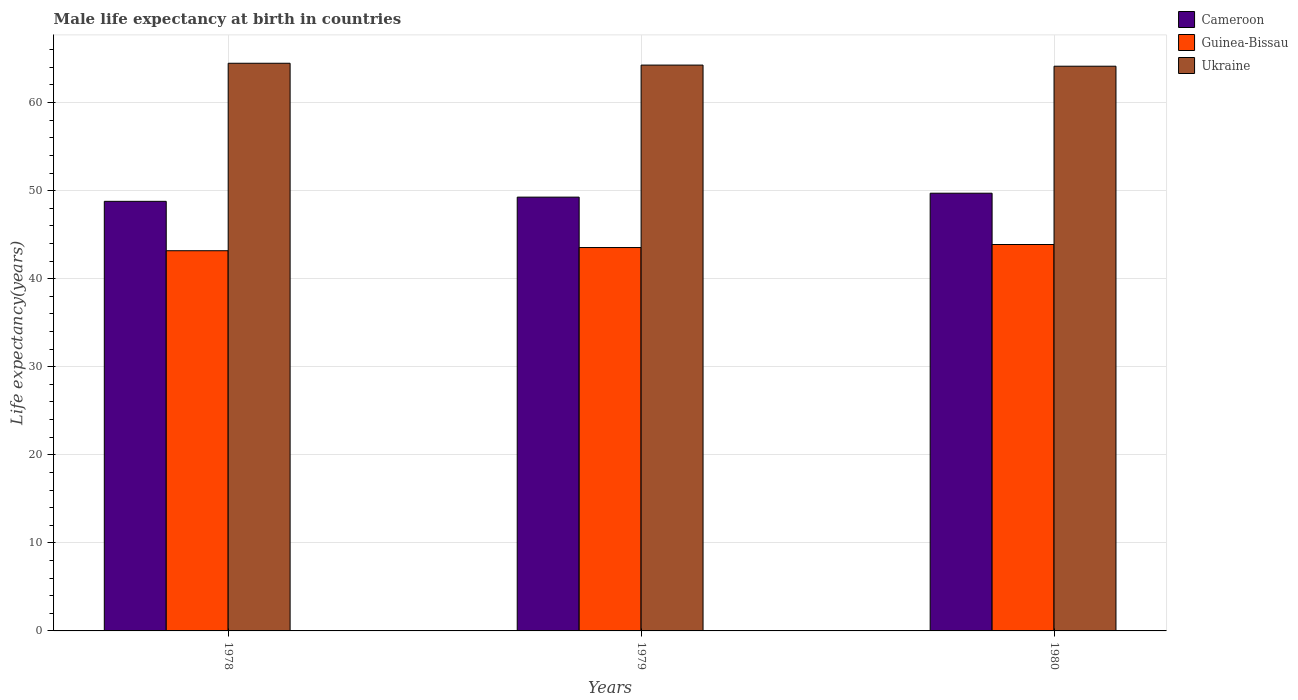How many different coloured bars are there?
Give a very brief answer. 3. Are the number of bars per tick equal to the number of legend labels?
Give a very brief answer. Yes. How many bars are there on the 3rd tick from the left?
Keep it short and to the point. 3. What is the label of the 2nd group of bars from the left?
Your answer should be very brief. 1979. What is the male life expectancy at birth in Guinea-Bissau in 1979?
Offer a very short reply. 43.54. Across all years, what is the maximum male life expectancy at birth in Cameroon?
Give a very brief answer. 49.71. Across all years, what is the minimum male life expectancy at birth in Cameroon?
Offer a very short reply. 48.79. In which year was the male life expectancy at birth in Ukraine minimum?
Your response must be concise. 1980. What is the total male life expectancy at birth in Ukraine in the graph?
Keep it short and to the point. 192.86. What is the difference between the male life expectancy at birth in Guinea-Bissau in 1978 and that in 1979?
Offer a very short reply. -0.36. What is the difference between the male life expectancy at birth in Cameroon in 1978 and the male life expectancy at birth in Guinea-Bissau in 1980?
Provide a short and direct response. 4.9. What is the average male life expectancy at birth in Ukraine per year?
Your response must be concise. 64.29. In the year 1978, what is the difference between the male life expectancy at birth in Guinea-Bissau and male life expectancy at birth in Ukraine?
Keep it short and to the point. -21.29. In how many years, is the male life expectancy at birth in Guinea-Bissau greater than 2 years?
Offer a very short reply. 3. What is the ratio of the male life expectancy at birth in Guinea-Bissau in 1978 to that in 1980?
Ensure brevity in your answer.  0.98. Is the difference between the male life expectancy at birth in Guinea-Bissau in 1978 and 1980 greater than the difference between the male life expectancy at birth in Ukraine in 1978 and 1980?
Provide a succinct answer. No. What is the difference between the highest and the second highest male life expectancy at birth in Ukraine?
Keep it short and to the point. 0.21. What is the difference between the highest and the lowest male life expectancy at birth in Guinea-Bissau?
Ensure brevity in your answer.  0.71. Is the sum of the male life expectancy at birth in Ukraine in 1978 and 1980 greater than the maximum male life expectancy at birth in Cameroon across all years?
Offer a terse response. Yes. What does the 3rd bar from the left in 1979 represents?
Keep it short and to the point. Ukraine. What does the 2nd bar from the right in 1978 represents?
Your response must be concise. Guinea-Bissau. Is it the case that in every year, the sum of the male life expectancy at birth in Guinea-Bissau and male life expectancy at birth in Cameroon is greater than the male life expectancy at birth in Ukraine?
Your answer should be compact. Yes. How many bars are there?
Provide a short and direct response. 9. Are all the bars in the graph horizontal?
Offer a very short reply. No. How many years are there in the graph?
Make the answer very short. 3. What is the difference between two consecutive major ticks on the Y-axis?
Keep it short and to the point. 10. Does the graph contain any zero values?
Provide a succinct answer. No. How are the legend labels stacked?
Your response must be concise. Vertical. What is the title of the graph?
Offer a very short reply. Male life expectancy at birth in countries. What is the label or title of the Y-axis?
Make the answer very short. Life expectancy(years). What is the Life expectancy(years) in Cameroon in 1978?
Provide a succinct answer. 48.79. What is the Life expectancy(years) of Guinea-Bissau in 1978?
Offer a terse response. 43.18. What is the Life expectancy(years) of Ukraine in 1978?
Give a very brief answer. 64.47. What is the Life expectancy(years) of Cameroon in 1979?
Give a very brief answer. 49.26. What is the Life expectancy(years) of Guinea-Bissau in 1979?
Offer a terse response. 43.54. What is the Life expectancy(years) of Ukraine in 1979?
Give a very brief answer. 64.26. What is the Life expectancy(years) in Cameroon in 1980?
Offer a terse response. 49.71. What is the Life expectancy(years) of Guinea-Bissau in 1980?
Make the answer very short. 43.88. What is the Life expectancy(years) in Ukraine in 1980?
Offer a terse response. 64.13. Across all years, what is the maximum Life expectancy(years) of Cameroon?
Your response must be concise. 49.71. Across all years, what is the maximum Life expectancy(years) of Guinea-Bissau?
Provide a short and direct response. 43.88. Across all years, what is the maximum Life expectancy(years) in Ukraine?
Your response must be concise. 64.47. Across all years, what is the minimum Life expectancy(years) in Cameroon?
Give a very brief answer. 48.79. Across all years, what is the minimum Life expectancy(years) in Guinea-Bissau?
Offer a terse response. 43.18. Across all years, what is the minimum Life expectancy(years) of Ukraine?
Offer a very short reply. 64.13. What is the total Life expectancy(years) in Cameroon in the graph?
Keep it short and to the point. 147.76. What is the total Life expectancy(years) of Guinea-Bissau in the graph?
Offer a very short reply. 130.6. What is the total Life expectancy(years) in Ukraine in the graph?
Your response must be concise. 192.86. What is the difference between the Life expectancy(years) of Cameroon in 1978 and that in 1979?
Your answer should be very brief. -0.48. What is the difference between the Life expectancy(years) of Guinea-Bissau in 1978 and that in 1979?
Provide a short and direct response. -0.36. What is the difference between the Life expectancy(years) of Ukraine in 1978 and that in 1979?
Offer a terse response. 0.21. What is the difference between the Life expectancy(years) in Cameroon in 1978 and that in 1980?
Your response must be concise. -0.92. What is the difference between the Life expectancy(years) in Guinea-Bissau in 1978 and that in 1980?
Your answer should be very brief. -0.71. What is the difference between the Life expectancy(years) of Ukraine in 1978 and that in 1980?
Provide a succinct answer. 0.34. What is the difference between the Life expectancy(years) in Cameroon in 1979 and that in 1980?
Offer a very short reply. -0.45. What is the difference between the Life expectancy(years) in Guinea-Bissau in 1979 and that in 1980?
Keep it short and to the point. -0.34. What is the difference between the Life expectancy(years) of Ukraine in 1979 and that in 1980?
Make the answer very short. 0.13. What is the difference between the Life expectancy(years) in Cameroon in 1978 and the Life expectancy(years) in Guinea-Bissau in 1979?
Offer a terse response. 5.25. What is the difference between the Life expectancy(years) in Cameroon in 1978 and the Life expectancy(years) in Ukraine in 1979?
Give a very brief answer. -15.47. What is the difference between the Life expectancy(years) of Guinea-Bissau in 1978 and the Life expectancy(years) of Ukraine in 1979?
Ensure brevity in your answer.  -21.08. What is the difference between the Life expectancy(years) in Cameroon in 1978 and the Life expectancy(years) in Guinea-Bissau in 1980?
Give a very brief answer. 4.9. What is the difference between the Life expectancy(years) in Cameroon in 1978 and the Life expectancy(years) in Ukraine in 1980?
Ensure brevity in your answer.  -15.35. What is the difference between the Life expectancy(years) in Guinea-Bissau in 1978 and the Life expectancy(years) in Ukraine in 1980?
Your answer should be very brief. -20.95. What is the difference between the Life expectancy(years) of Cameroon in 1979 and the Life expectancy(years) of Guinea-Bissau in 1980?
Offer a very short reply. 5.38. What is the difference between the Life expectancy(years) of Cameroon in 1979 and the Life expectancy(years) of Ukraine in 1980?
Provide a short and direct response. -14.87. What is the difference between the Life expectancy(years) of Guinea-Bissau in 1979 and the Life expectancy(years) of Ukraine in 1980?
Ensure brevity in your answer.  -20.59. What is the average Life expectancy(years) in Cameroon per year?
Give a very brief answer. 49.25. What is the average Life expectancy(years) in Guinea-Bissau per year?
Make the answer very short. 43.53. What is the average Life expectancy(years) in Ukraine per year?
Offer a very short reply. 64.29. In the year 1978, what is the difference between the Life expectancy(years) in Cameroon and Life expectancy(years) in Guinea-Bissau?
Give a very brief answer. 5.61. In the year 1978, what is the difference between the Life expectancy(years) in Cameroon and Life expectancy(years) in Ukraine?
Your answer should be compact. -15.68. In the year 1978, what is the difference between the Life expectancy(years) of Guinea-Bissau and Life expectancy(years) of Ukraine?
Offer a very short reply. -21.29. In the year 1979, what is the difference between the Life expectancy(years) in Cameroon and Life expectancy(years) in Guinea-Bissau?
Offer a very short reply. 5.72. In the year 1979, what is the difference between the Life expectancy(years) of Cameroon and Life expectancy(years) of Ukraine?
Offer a very short reply. -15. In the year 1979, what is the difference between the Life expectancy(years) in Guinea-Bissau and Life expectancy(years) in Ukraine?
Give a very brief answer. -20.72. In the year 1980, what is the difference between the Life expectancy(years) in Cameroon and Life expectancy(years) in Guinea-Bissau?
Your answer should be very brief. 5.83. In the year 1980, what is the difference between the Life expectancy(years) of Cameroon and Life expectancy(years) of Ukraine?
Give a very brief answer. -14.42. In the year 1980, what is the difference between the Life expectancy(years) of Guinea-Bissau and Life expectancy(years) of Ukraine?
Keep it short and to the point. -20.25. What is the ratio of the Life expectancy(years) in Cameroon in 1978 to that in 1979?
Give a very brief answer. 0.99. What is the ratio of the Life expectancy(years) of Guinea-Bissau in 1978 to that in 1979?
Keep it short and to the point. 0.99. What is the ratio of the Life expectancy(years) of Cameroon in 1978 to that in 1980?
Ensure brevity in your answer.  0.98. What is the ratio of the Life expectancy(years) in Guinea-Bissau in 1978 to that in 1980?
Ensure brevity in your answer.  0.98. What is the ratio of the Life expectancy(years) of Ukraine in 1979 to that in 1980?
Offer a very short reply. 1. What is the difference between the highest and the second highest Life expectancy(years) in Cameroon?
Offer a terse response. 0.45. What is the difference between the highest and the second highest Life expectancy(years) of Guinea-Bissau?
Provide a short and direct response. 0.34. What is the difference between the highest and the second highest Life expectancy(years) in Ukraine?
Your response must be concise. 0.21. What is the difference between the highest and the lowest Life expectancy(years) in Cameroon?
Offer a very short reply. 0.92. What is the difference between the highest and the lowest Life expectancy(years) in Guinea-Bissau?
Provide a short and direct response. 0.71. What is the difference between the highest and the lowest Life expectancy(years) in Ukraine?
Provide a succinct answer. 0.34. 